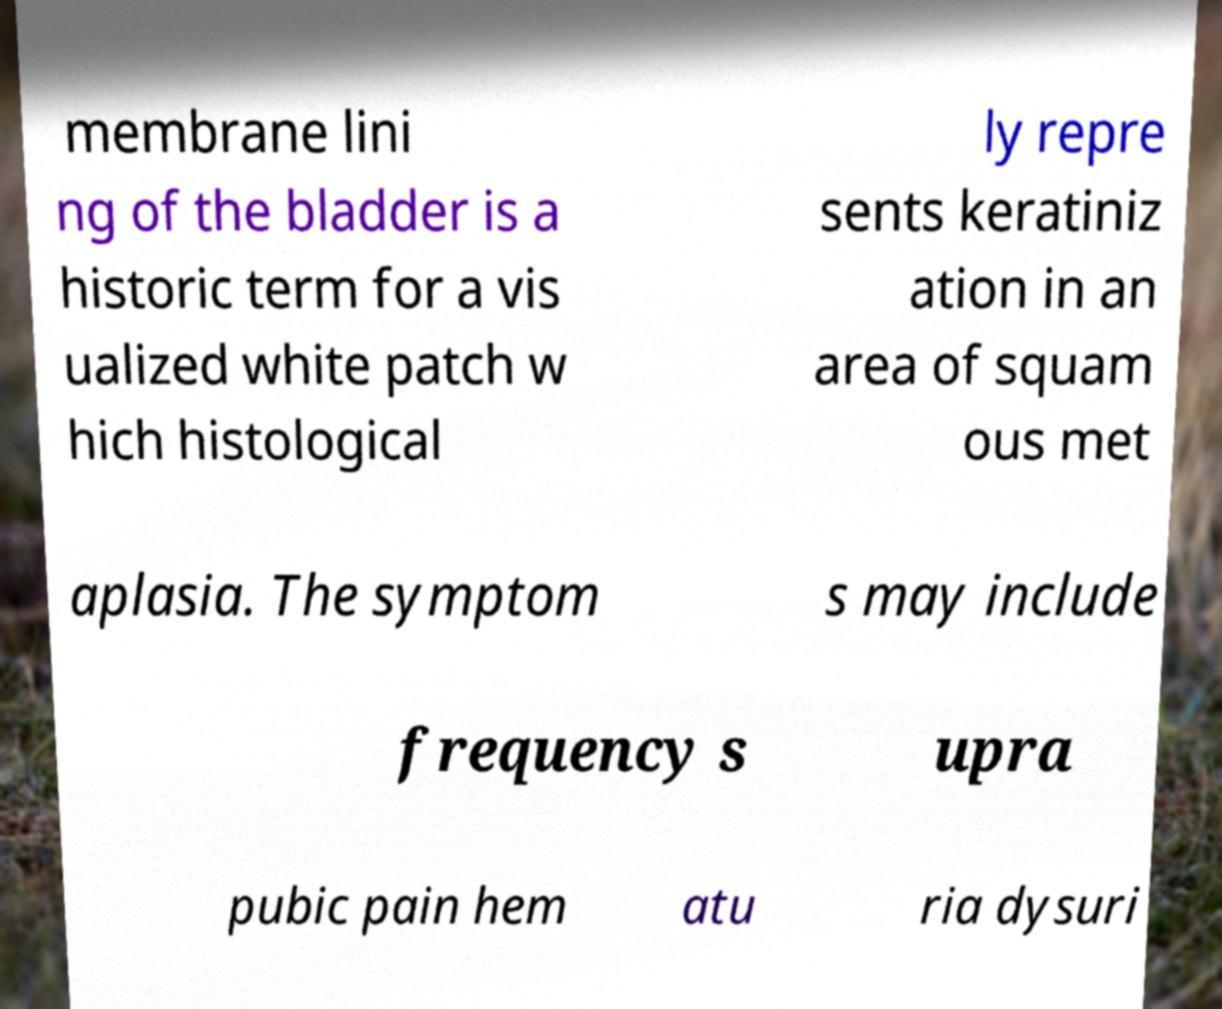Please identify and transcribe the text found in this image. membrane lini ng of the bladder is a historic term for a vis ualized white patch w hich histological ly repre sents keratiniz ation in an area of squam ous met aplasia. The symptom s may include frequency s upra pubic pain hem atu ria dysuri 